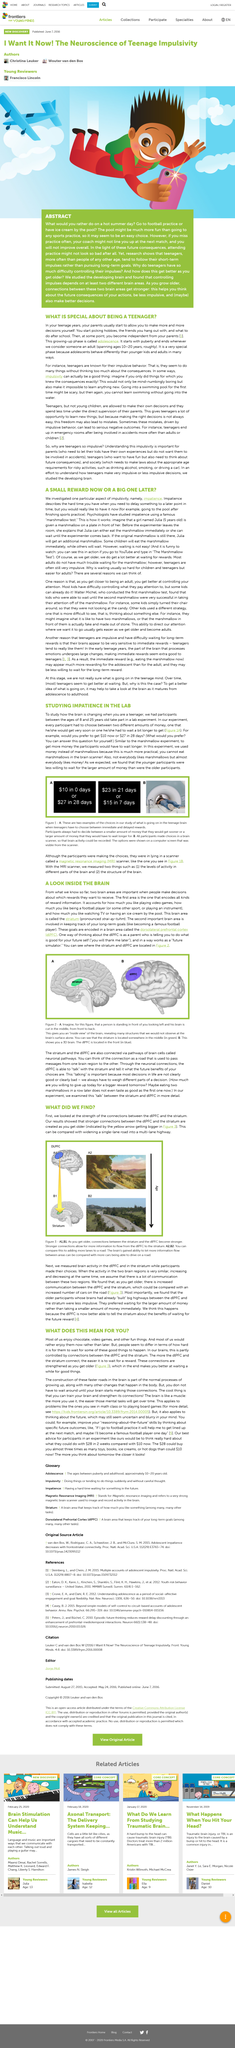Point out several critical features in this image. In order to study impatience in the lab experiment, participants were presented with a choice between two different amounts of money. The figure illustrates a 3D representation of a brain, revealing its various structures and features. The number of brain areas necessary for decision-making is two, according to research. The two options for money earned in a scanner were presented to participants while their brain activity was being monitored inside the scanner. The striatum is the brain area that encodes reward information. 